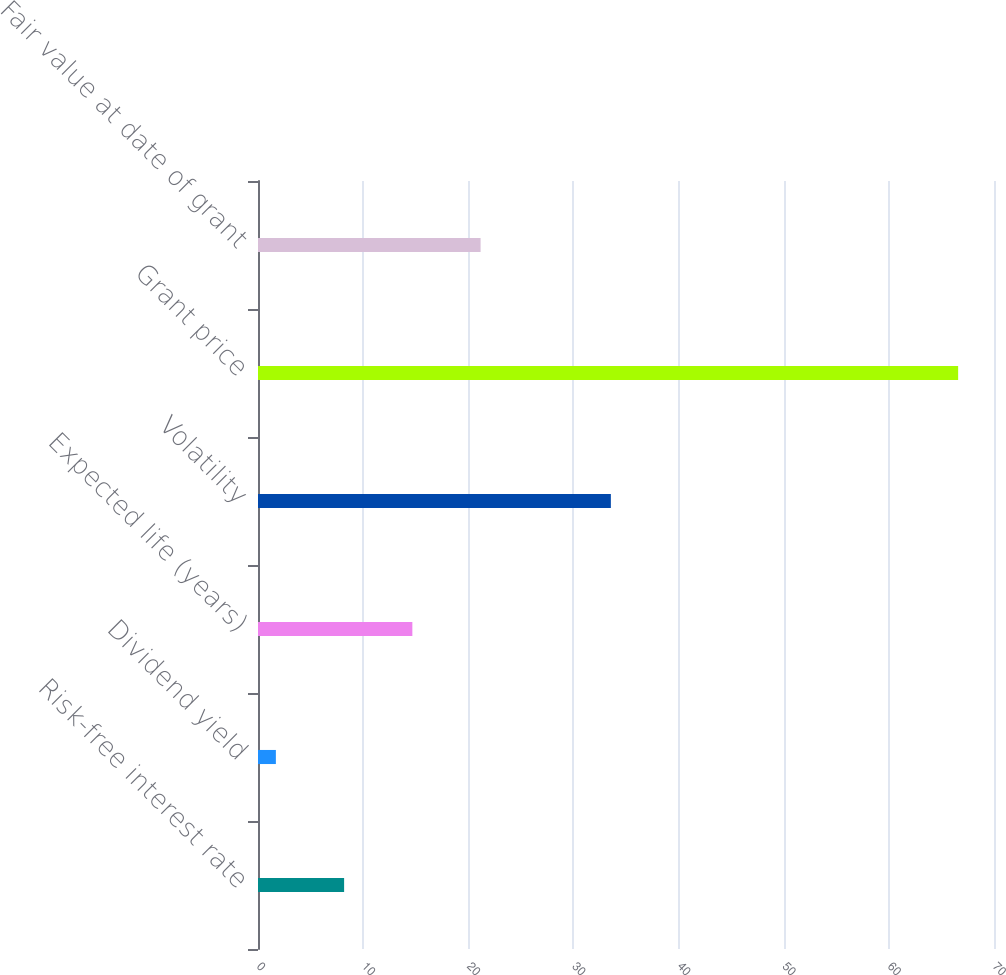Convert chart. <chart><loc_0><loc_0><loc_500><loc_500><bar_chart><fcel>Risk-free interest rate<fcel>Dividend yield<fcel>Expected life (years)<fcel>Volatility<fcel>Grant price<fcel>Fair value at date of grant<nl><fcel>8.19<fcel>1.7<fcel>14.68<fcel>33.56<fcel>66.59<fcel>21.17<nl></chart> 